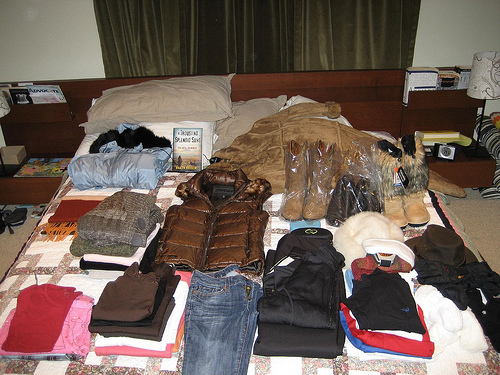<image>
Can you confirm if the shoe is to the left of the shoe? Yes. From this viewpoint, the shoe is positioned to the left side relative to the shoe. 